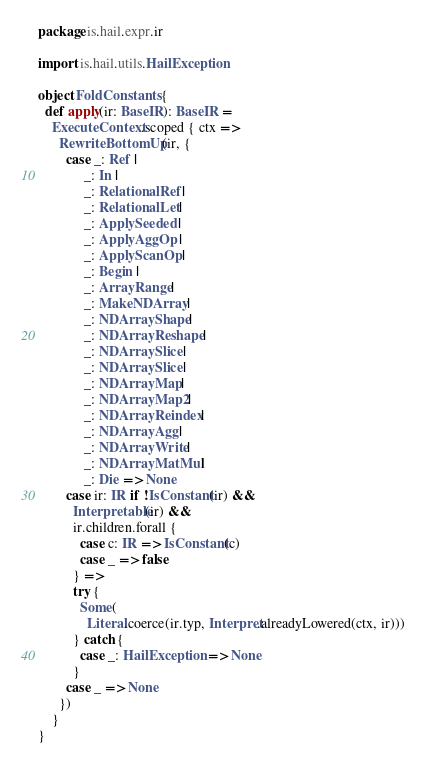<code> <loc_0><loc_0><loc_500><loc_500><_Scala_>package is.hail.expr.ir

import is.hail.utils.HailException

object FoldConstants {
  def apply(ir: BaseIR): BaseIR =
    ExecuteContext.scoped { ctx =>
      RewriteBottomUp(ir, {
        case _: Ref |
             _: In |
             _: RelationalRef |
             _: RelationalLet |
             _: ApplySeeded |
             _: ApplyAggOp |
             _: ApplyScanOp |
             _: Begin |
             _: ArrayRange |
             _: MakeNDArray |
             _: NDArrayShape |
             _: NDArrayReshape |
             _: NDArraySlice |
             _: NDArraySlice |
             _: NDArrayMap |
             _: NDArrayMap2 |
             _: NDArrayReindex |
             _: NDArrayAgg |
             _: NDArrayWrite |
             _: NDArrayMatMul |
             _: Die => None
        case ir: IR if !IsConstant(ir) &&
          Interpretable(ir) &&
          ir.children.forall {
            case c: IR => IsConstant(c)
            case _ => false
          } =>
          try {
            Some(
              Literal.coerce(ir.typ, Interpret.alreadyLowered(ctx, ir)))
          } catch {
            case _: HailException => None
          }
        case _ => None
      })
    }
}</code> 